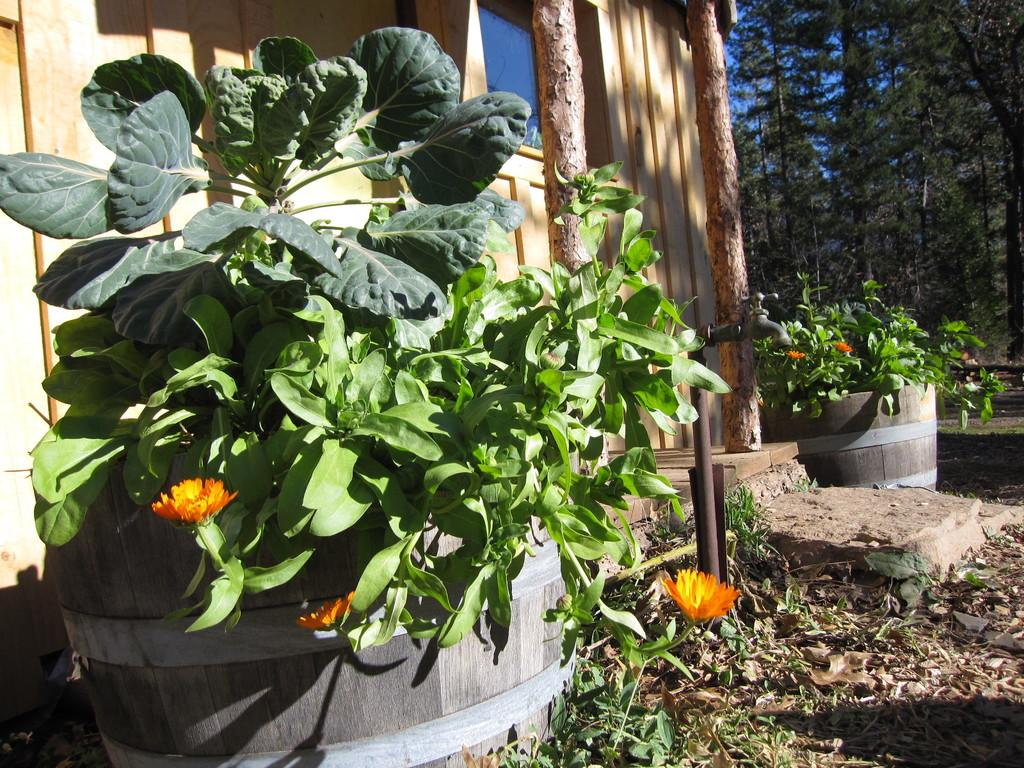What type of plant is in the image? There is a green plant in the image. How is the plant contained or held? The plant is in a wooden pot. Where is the pot placed? The pot is placed on the ground. What can be seen in the background of the image? There is a wooden house and trees in the background of the image. Can you tell me how many basketballs are visible in the image? There are no basketballs present in the image. What is a good example of an elbow in the image? There is no mention of an elbow in the image, as it features a green plant in a wooden pot, a wooden house, and trees in the background. 